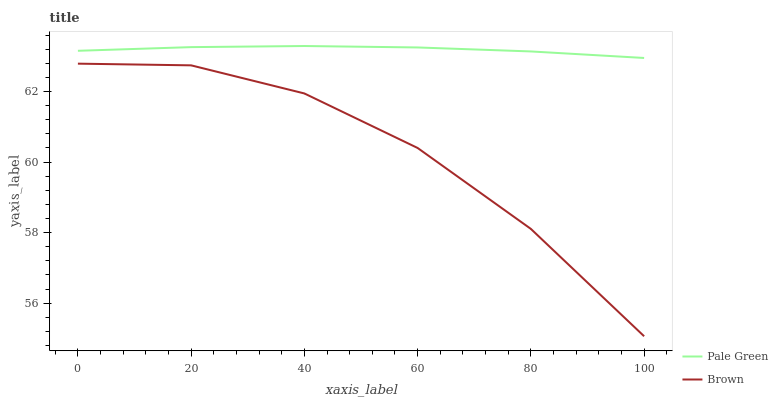Does Brown have the minimum area under the curve?
Answer yes or no. Yes. Does Pale Green have the maximum area under the curve?
Answer yes or no. Yes. Does Pale Green have the minimum area under the curve?
Answer yes or no. No. Is Pale Green the smoothest?
Answer yes or no. Yes. Is Brown the roughest?
Answer yes or no. Yes. Is Pale Green the roughest?
Answer yes or no. No. Does Brown have the lowest value?
Answer yes or no. Yes. Does Pale Green have the lowest value?
Answer yes or no. No. Does Pale Green have the highest value?
Answer yes or no. Yes. Is Brown less than Pale Green?
Answer yes or no. Yes. Is Pale Green greater than Brown?
Answer yes or no. Yes. Does Brown intersect Pale Green?
Answer yes or no. No. 